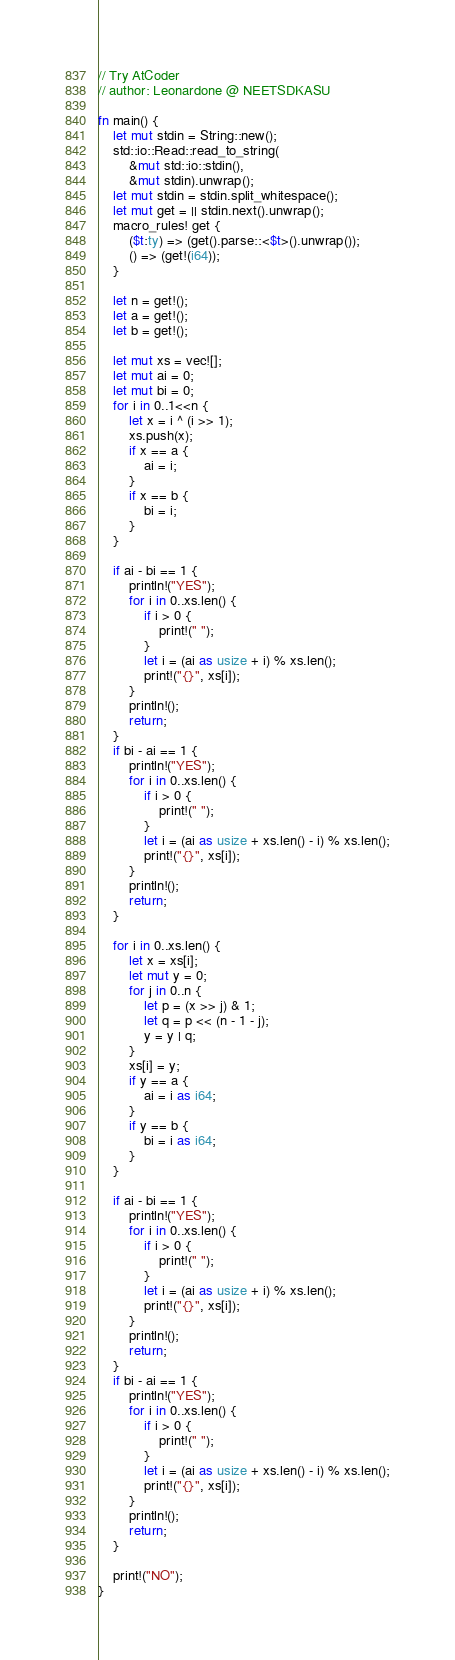<code> <loc_0><loc_0><loc_500><loc_500><_Rust_>// Try AtCoder
// author: Leonardone @ NEETSDKASU

fn main() {
	let mut stdin = String::new();
    std::io::Read::read_to_string(
    	&mut std::io::stdin(),
        &mut stdin).unwrap();
	let mut stdin = stdin.split_whitespace();
    let mut get = || stdin.next().unwrap();
    macro_rules! get {
    	($t:ty) => (get().parse::<$t>().unwrap());
        () => (get!(i64));
    }
    
    let n = get!();
    let a = get!();
    let b = get!();
    
    let mut xs = vec![];
    let mut ai = 0;
    let mut bi = 0;
    for i in 0..1<<n {
    	let x = i ^ (i >> 1);
        xs.push(x);
        if x == a {
        	ai = i;
        }
        if x == b {
        	bi = i;
        }
    }
    
    if ai - bi == 1 {
    	println!("YES");
        for i in 0..xs.len() {
        	if i > 0 {
            	print!(" ");
            }
        	let i = (ai as usize + i) % xs.len();
            print!("{}", xs[i]);
        }
        println!();
        return;
    }
    if bi - ai == 1 {
    	println!("YES");
        for i in 0..xs.len() {
        	if i > 0 {
            	print!(" ");
            }
        	let i = (ai as usize + xs.len() - i) % xs.len();
            print!("{}", xs[i]);
        }
        println!();
        return;
    }
    
    for i in 0..xs.len() {
    	let x = xs[i];
        let mut y = 0;
        for j in 0..n {
        	let p = (x >> j) & 1;
            let q = p << (n - 1 - j);
            y = y | q;
        }
        xs[i] = y;
        if y == a {
        	ai = i as i64;
        }
        if y == b {
        	bi = i as i64;
        }
    }
	
    if ai - bi == 1 {
    	println!("YES");
        for i in 0..xs.len() {
        	if i > 0 {
            	print!(" ");
            }
        	let i = (ai as usize + i) % xs.len();
            print!("{}", xs[i]);
        }
        println!();
        return;
    }
    if bi - ai == 1 {
    	println!("YES");
        for i in 0..xs.len() {
        	if i > 0 {
            	print!(" ");
            }
        	let i = (ai as usize + xs.len() - i) % xs.len();
            print!("{}", xs[i]);
        }
        println!();
        return;
    }

	print!("NO");
}</code> 